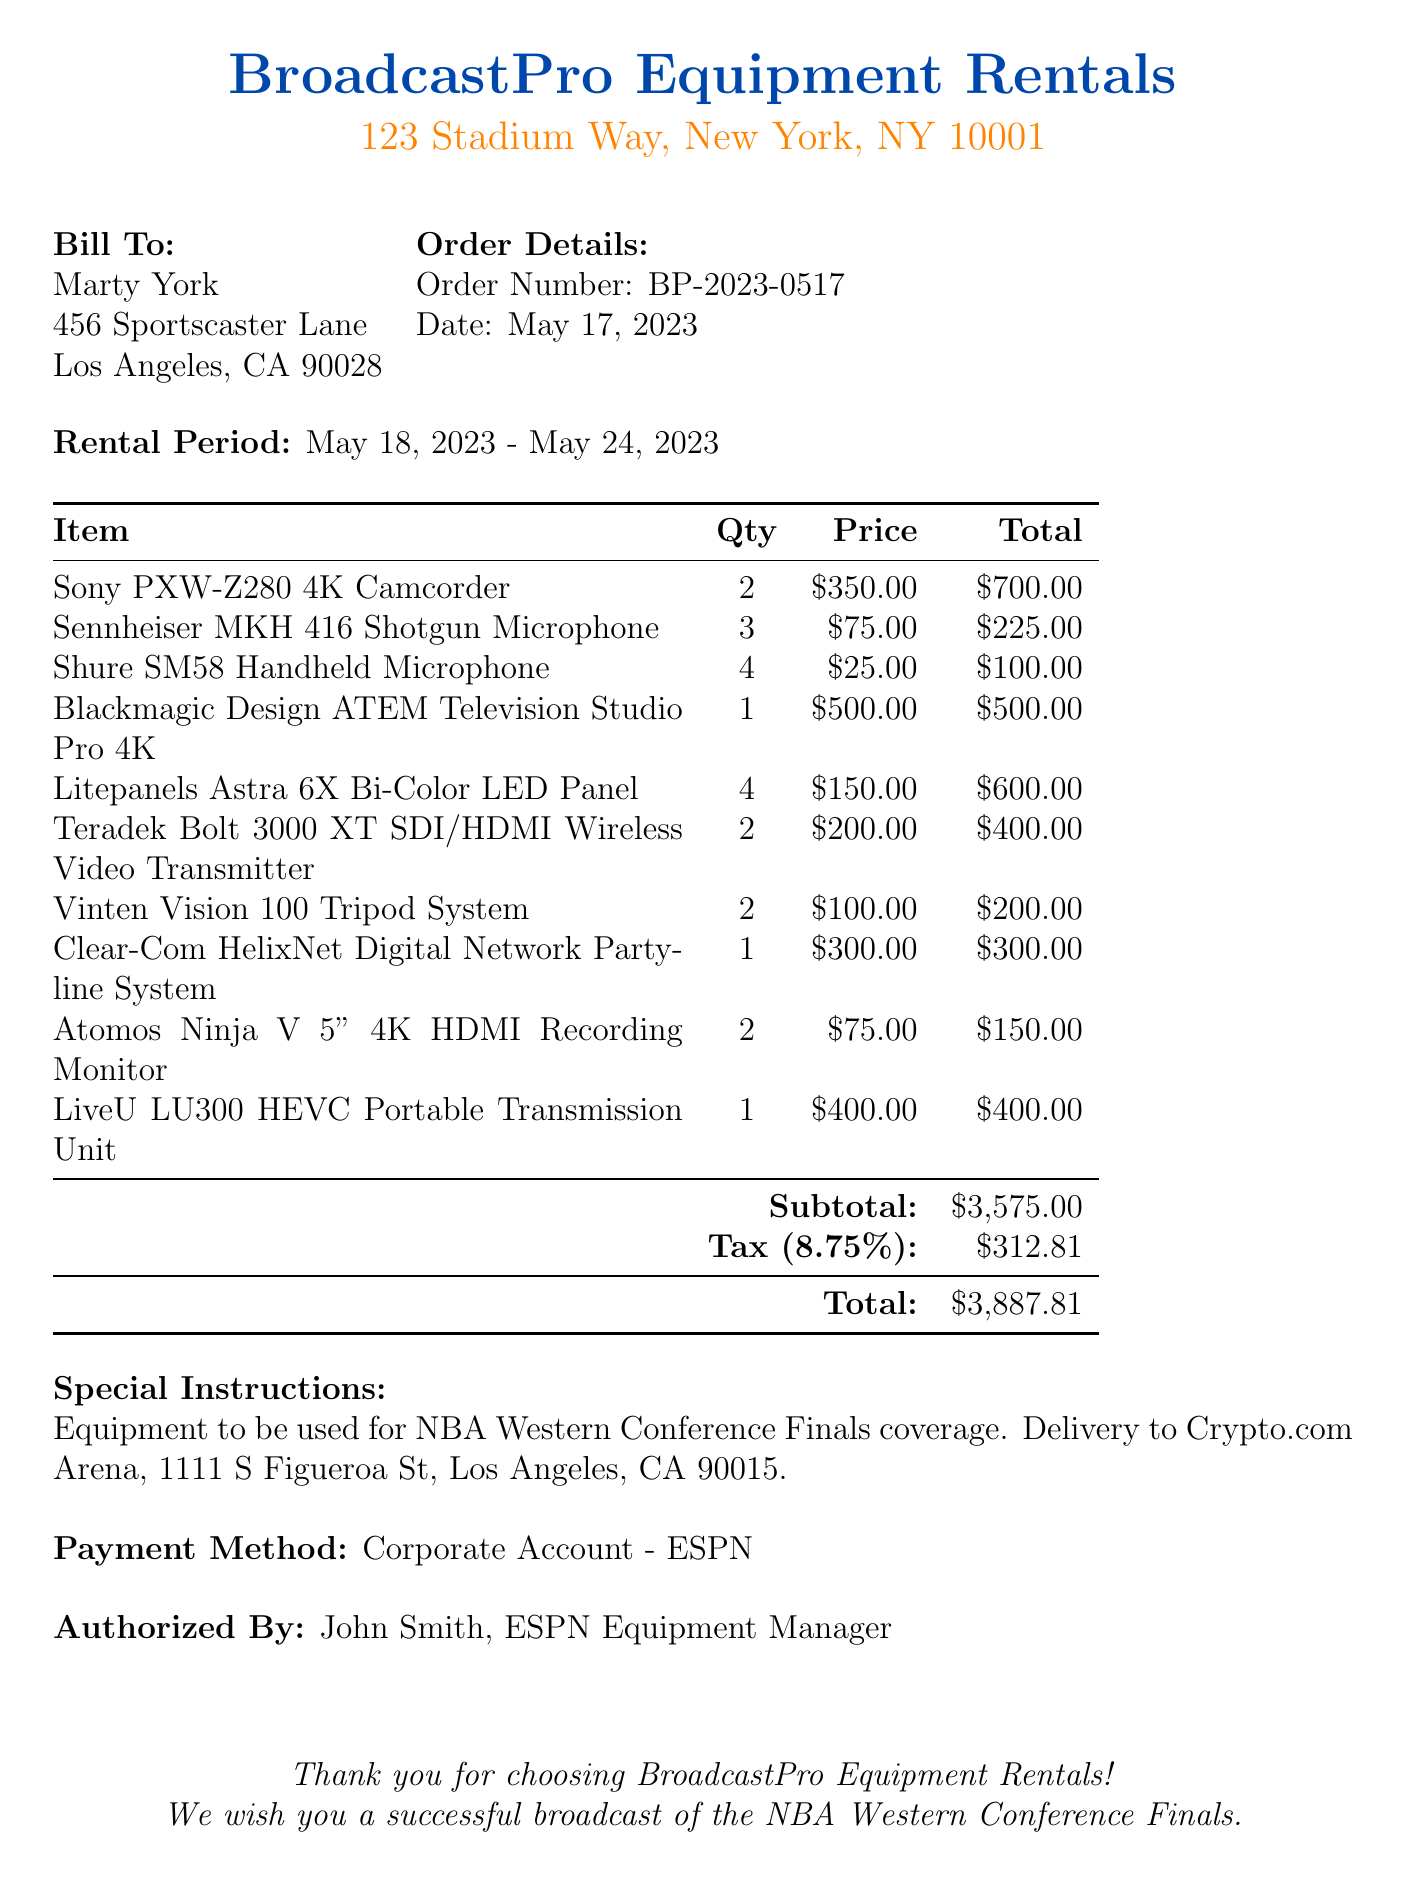What is the company name? The company name listed on the receipt is the official name of the renting provider.
Answer: BroadcastPro Equipment Rentals Who is the customer? The customer is the individual or entity renting the equipment, identified by their name.
Answer: Marty York What is the order number? The order number is a unique identifier for this rental transaction.
Answer: BP-2023-0517 What is the total amount due? The total amount is the final charge for the rental equipment after tax is applied.
Answer: $3,887.81 How many Blackmagic Design ATEM Television Studio Pro 4K were rented? This is the quantity of a specific equipment item rented by the customer as indicated in the receipt.
Answer: 1 What were the rental dates? The rental dates indicate the start and end periods for the equipment rental.
Answer: May 18, 2023 - May 24, 2023 What is the tax rate applied? The tax rate indicates the percentage charged on the total amount before tax.
Answer: 8.75% What type of equipment was rented for the NBA coverage? This refers to the category or nature of the event for which the equipment is being utilized, as specified in the receipt.
Answer: NBA Western Conference Finals Who authorized the rental? The individual who has given approval for the transaction on behalf of the renting party is specified here.
Answer: John Smith, ESPN Equipment Manager 